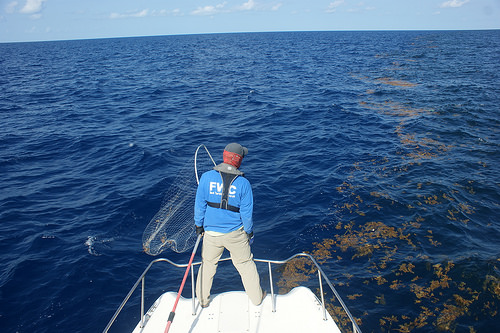<image>
Is there a sea under the man? Yes. The sea is positioned underneath the man, with the man above it in the vertical space. Is the sea in front of the man? Yes. The sea is positioned in front of the man, appearing closer to the camera viewpoint. 